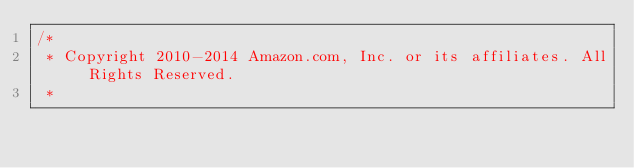Convert code to text. <code><loc_0><loc_0><loc_500><loc_500><_C#_>/*
 * Copyright 2010-2014 Amazon.com, Inc. or its affiliates. All Rights Reserved.
 * </code> 